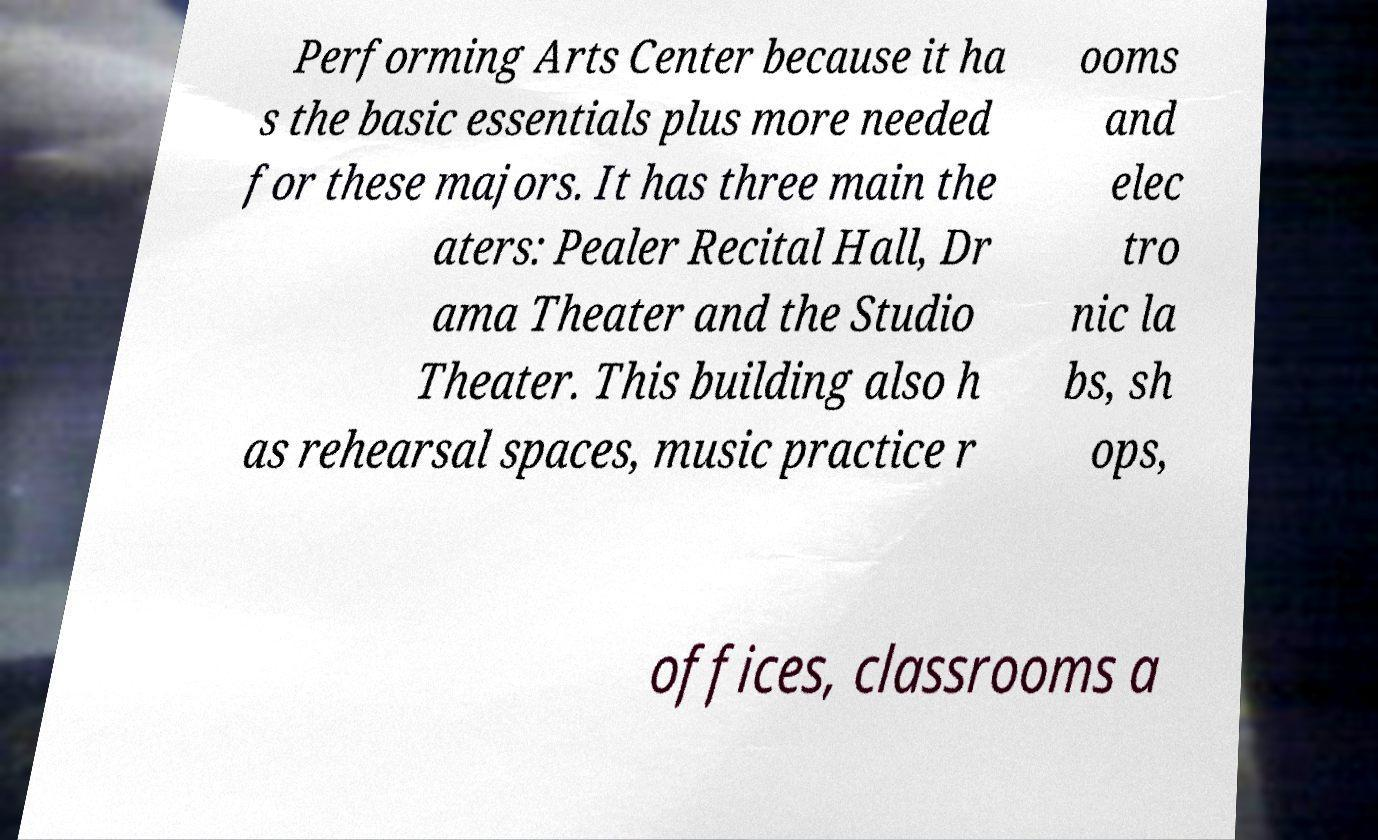For documentation purposes, I need the text within this image transcribed. Could you provide that? Performing Arts Center because it ha s the basic essentials plus more needed for these majors. It has three main the aters: Pealer Recital Hall, Dr ama Theater and the Studio Theater. This building also h as rehearsal spaces, music practice r ooms and elec tro nic la bs, sh ops, offices, classrooms a 